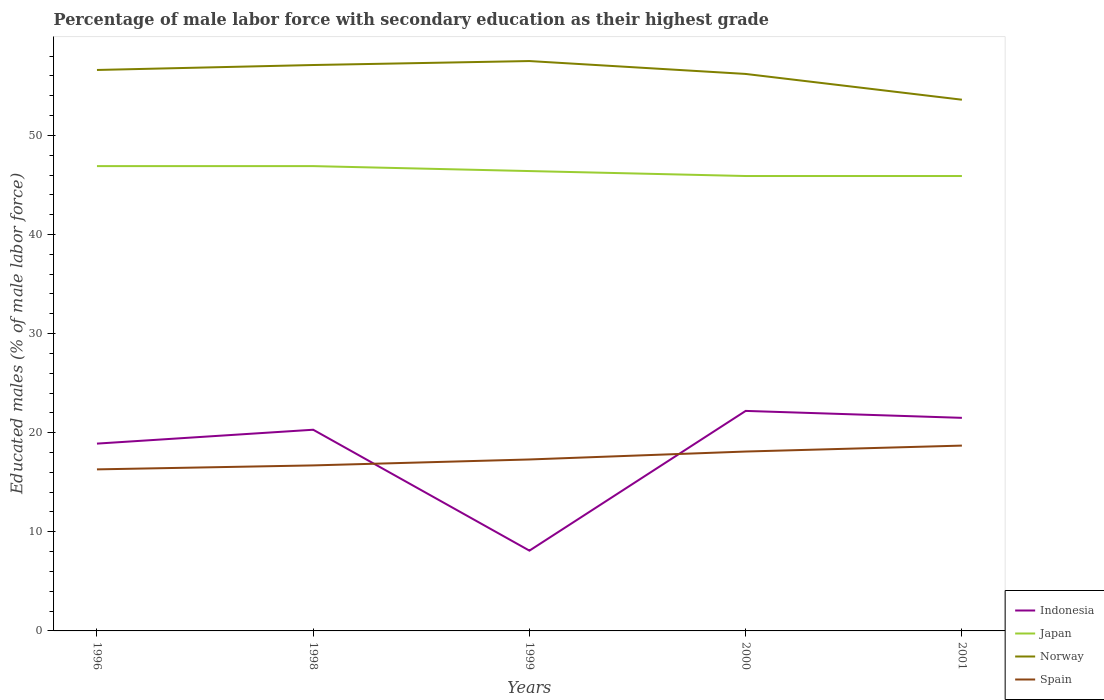How many different coloured lines are there?
Provide a succinct answer. 4. Is the number of lines equal to the number of legend labels?
Keep it short and to the point. Yes. Across all years, what is the maximum percentage of male labor force with secondary education in Spain?
Offer a very short reply. 16.3. What is the total percentage of male labor force with secondary education in Norway in the graph?
Make the answer very short. 0.4. What is the difference between the highest and the second highest percentage of male labor force with secondary education in Norway?
Keep it short and to the point. 3.9. What is the difference between the highest and the lowest percentage of male labor force with secondary education in Indonesia?
Provide a short and direct response. 4. How many years are there in the graph?
Give a very brief answer. 5. What is the difference between two consecutive major ticks on the Y-axis?
Offer a very short reply. 10. Does the graph contain grids?
Offer a terse response. No. Where does the legend appear in the graph?
Ensure brevity in your answer.  Bottom right. How many legend labels are there?
Provide a short and direct response. 4. How are the legend labels stacked?
Offer a terse response. Vertical. What is the title of the graph?
Provide a short and direct response. Percentage of male labor force with secondary education as their highest grade. Does "Congo (Republic)" appear as one of the legend labels in the graph?
Offer a terse response. No. What is the label or title of the Y-axis?
Offer a terse response. Educated males (% of male labor force). What is the Educated males (% of male labor force) of Indonesia in 1996?
Your answer should be compact. 18.9. What is the Educated males (% of male labor force) in Japan in 1996?
Provide a short and direct response. 46.9. What is the Educated males (% of male labor force) of Norway in 1996?
Ensure brevity in your answer.  56.6. What is the Educated males (% of male labor force) of Spain in 1996?
Your response must be concise. 16.3. What is the Educated males (% of male labor force) of Indonesia in 1998?
Ensure brevity in your answer.  20.3. What is the Educated males (% of male labor force) in Japan in 1998?
Ensure brevity in your answer.  46.9. What is the Educated males (% of male labor force) in Norway in 1998?
Offer a terse response. 57.1. What is the Educated males (% of male labor force) of Spain in 1998?
Give a very brief answer. 16.7. What is the Educated males (% of male labor force) in Indonesia in 1999?
Provide a short and direct response. 8.1. What is the Educated males (% of male labor force) in Japan in 1999?
Your answer should be compact. 46.4. What is the Educated males (% of male labor force) of Norway in 1999?
Your answer should be very brief. 57.5. What is the Educated males (% of male labor force) of Spain in 1999?
Make the answer very short. 17.3. What is the Educated males (% of male labor force) of Indonesia in 2000?
Your answer should be compact. 22.2. What is the Educated males (% of male labor force) of Japan in 2000?
Ensure brevity in your answer.  45.9. What is the Educated males (% of male labor force) in Norway in 2000?
Ensure brevity in your answer.  56.2. What is the Educated males (% of male labor force) in Spain in 2000?
Provide a succinct answer. 18.1. What is the Educated males (% of male labor force) in Japan in 2001?
Make the answer very short. 45.9. What is the Educated males (% of male labor force) in Norway in 2001?
Keep it short and to the point. 53.6. What is the Educated males (% of male labor force) in Spain in 2001?
Provide a succinct answer. 18.7. Across all years, what is the maximum Educated males (% of male labor force) in Indonesia?
Give a very brief answer. 22.2. Across all years, what is the maximum Educated males (% of male labor force) of Japan?
Offer a terse response. 46.9. Across all years, what is the maximum Educated males (% of male labor force) of Norway?
Offer a terse response. 57.5. Across all years, what is the maximum Educated males (% of male labor force) in Spain?
Provide a short and direct response. 18.7. Across all years, what is the minimum Educated males (% of male labor force) of Indonesia?
Provide a succinct answer. 8.1. Across all years, what is the minimum Educated males (% of male labor force) of Japan?
Your answer should be very brief. 45.9. Across all years, what is the minimum Educated males (% of male labor force) of Norway?
Make the answer very short. 53.6. Across all years, what is the minimum Educated males (% of male labor force) of Spain?
Your response must be concise. 16.3. What is the total Educated males (% of male labor force) of Indonesia in the graph?
Provide a short and direct response. 91. What is the total Educated males (% of male labor force) of Japan in the graph?
Offer a very short reply. 232. What is the total Educated males (% of male labor force) in Norway in the graph?
Ensure brevity in your answer.  281. What is the total Educated males (% of male labor force) in Spain in the graph?
Your response must be concise. 87.1. What is the difference between the Educated males (% of male labor force) of Indonesia in 1996 and that in 1998?
Provide a succinct answer. -1.4. What is the difference between the Educated males (% of male labor force) in Japan in 1996 and that in 1998?
Offer a very short reply. 0. What is the difference between the Educated males (% of male labor force) in Norway in 1996 and that in 1998?
Your answer should be very brief. -0.5. What is the difference between the Educated males (% of male labor force) of Indonesia in 1996 and that in 1999?
Your answer should be very brief. 10.8. What is the difference between the Educated males (% of male labor force) in Japan in 1996 and that in 1999?
Your response must be concise. 0.5. What is the difference between the Educated males (% of male labor force) of Norway in 1996 and that in 1999?
Your answer should be compact. -0.9. What is the difference between the Educated males (% of male labor force) in Indonesia in 1996 and that in 2000?
Ensure brevity in your answer.  -3.3. What is the difference between the Educated males (% of male labor force) in Spain in 1996 and that in 2000?
Make the answer very short. -1.8. What is the difference between the Educated males (% of male labor force) in Japan in 1996 and that in 2001?
Keep it short and to the point. 1. What is the difference between the Educated males (% of male labor force) of Norway in 1996 and that in 2001?
Your answer should be very brief. 3. What is the difference between the Educated males (% of male labor force) in Spain in 1996 and that in 2001?
Offer a very short reply. -2.4. What is the difference between the Educated males (% of male labor force) in Indonesia in 1998 and that in 1999?
Offer a very short reply. 12.2. What is the difference between the Educated males (% of male labor force) in Japan in 1998 and that in 1999?
Offer a terse response. 0.5. What is the difference between the Educated males (% of male labor force) in Norway in 1998 and that in 1999?
Offer a terse response. -0.4. What is the difference between the Educated males (% of male labor force) of Spain in 1998 and that in 1999?
Offer a terse response. -0.6. What is the difference between the Educated males (% of male labor force) of Norway in 1998 and that in 2000?
Provide a succinct answer. 0.9. What is the difference between the Educated males (% of male labor force) in Spain in 1998 and that in 2000?
Give a very brief answer. -1.4. What is the difference between the Educated males (% of male labor force) of Indonesia in 1998 and that in 2001?
Make the answer very short. -1.2. What is the difference between the Educated males (% of male labor force) of Japan in 1998 and that in 2001?
Offer a very short reply. 1. What is the difference between the Educated males (% of male labor force) of Norway in 1998 and that in 2001?
Your response must be concise. 3.5. What is the difference between the Educated males (% of male labor force) in Spain in 1998 and that in 2001?
Ensure brevity in your answer.  -2. What is the difference between the Educated males (% of male labor force) of Indonesia in 1999 and that in 2000?
Ensure brevity in your answer.  -14.1. What is the difference between the Educated males (% of male labor force) of Japan in 1999 and that in 2000?
Ensure brevity in your answer.  0.5. What is the difference between the Educated males (% of male labor force) of Spain in 1999 and that in 2000?
Provide a succinct answer. -0.8. What is the difference between the Educated males (% of male labor force) of Japan in 1999 and that in 2001?
Offer a terse response. 0.5. What is the difference between the Educated males (% of male labor force) in Spain in 1999 and that in 2001?
Your response must be concise. -1.4. What is the difference between the Educated males (% of male labor force) of Japan in 2000 and that in 2001?
Offer a terse response. 0. What is the difference between the Educated males (% of male labor force) in Spain in 2000 and that in 2001?
Ensure brevity in your answer.  -0.6. What is the difference between the Educated males (% of male labor force) in Indonesia in 1996 and the Educated males (% of male labor force) in Norway in 1998?
Provide a succinct answer. -38.2. What is the difference between the Educated males (% of male labor force) of Indonesia in 1996 and the Educated males (% of male labor force) of Spain in 1998?
Your response must be concise. 2.2. What is the difference between the Educated males (% of male labor force) in Japan in 1996 and the Educated males (% of male labor force) in Spain in 1998?
Provide a short and direct response. 30.2. What is the difference between the Educated males (% of male labor force) of Norway in 1996 and the Educated males (% of male labor force) of Spain in 1998?
Keep it short and to the point. 39.9. What is the difference between the Educated males (% of male labor force) in Indonesia in 1996 and the Educated males (% of male labor force) in Japan in 1999?
Give a very brief answer. -27.5. What is the difference between the Educated males (% of male labor force) in Indonesia in 1996 and the Educated males (% of male labor force) in Norway in 1999?
Your answer should be compact. -38.6. What is the difference between the Educated males (% of male labor force) of Indonesia in 1996 and the Educated males (% of male labor force) of Spain in 1999?
Keep it short and to the point. 1.6. What is the difference between the Educated males (% of male labor force) in Japan in 1996 and the Educated males (% of male labor force) in Spain in 1999?
Your response must be concise. 29.6. What is the difference between the Educated males (% of male labor force) of Norway in 1996 and the Educated males (% of male labor force) of Spain in 1999?
Give a very brief answer. 39.3. What is the difference between the Educated males (% of male labor force) of Indonesia in 1996 and the Educated males (% of male labor force) of Japan in 2000?
Provide a short and direct response. -27. What is the difference between the Educated males (% of male labor force) in Indonesia in 1996 and the Educated males (% of male labor force) in Norway in 2000?
Offer a very short reply. -37.3. What is the difference between the Educated males (% of male labor force) of Indonesia in 1996 and the Educated males (% of male labor force) of Spain in 2000?
Offer a very short reply. 0.8. What is the difference between the Educated males (% of male labor force) in Japan in 1996 and the Educated males (% of male labor force) in Spain in 2000?
Make the answer very short. 28.8. What is the difference between the Educated males (% of male labor force) in Norway in 1996 and the Educated males (% of male labor force) in Spain in 2000?
Keep it short and to the point. 38.5. What is the difference between the Educated males (% of male labor force) of Indonesia in 1996 and the Educated males (% of male labor force) of Norway in 2001?
Provide a succinct answer. -34.7. What is the difference between the Educated males (% of male labor force) in Indonesia in 1996 and the Educated males (% of male labor force) in Spain in 2001?
Your answer should be compact. 0.2. What is the difference between the Educated males (% of male labor force) in Japan in 1996 and the Educated males (% of male labor force) in Norway in 2001?
Your answer should be very brief. -6.7. What is the difference between the Educated males (% of male labor force) in Japan in 1996 and the Educated males (% of male labor force) in Spain in 2001?
Your answer should be compact. 28.2. What is the difference between the Educated males (% of male labor force) in Norway in 1996 and the Educated males (% of male labor force) in Spain in 2001?
Offer a very short reply. 37.9. What is the difference between the Educated males (% of male labor force) in Indonesia in 1998 and the Educated males (% of male labor force) in Japan in 1999?
Provide a short and direct response. -26.1. What is the difference between the Educated males (% of male labor force) in Indonesia in 1998 and the Educated males (% of male labor force) in Norway in 1999?
Your response must be concise. -37.2. What is the difference between the Educated males (% of male labor force) of Japan in 1998 and the Educated males (% of male labor force) of Norway in 1999?
Offer a terse response. -10.6. What is the difference between the Educated males (% of male labor force) in Japan in 1998 and the Educated males (% of male labor force) in Spain in 1999?
Your answer should be very brief. 29.6. What is the difference between the Educated males (% of male labor force) of Norway in 1998 and the Educated males (% of male labor force) of Spain in 1999?
Your answer should be compact. 39.8. What is the difference between the Educated males (% of male labor force) of Indonesia in 1998 and the Educated males (% of male labor force) of Japan in 2000?
Give a very brief answer. -25.6. What is the difference between the Educated males (% of male labor force) in Indonesia in 1998 and the Educated males (% of male labor force) in Norway in 2000?
Your answer should be very brief. -35.9. What is the difference between the Educated males (% of male labor force) of Indonesia in 1998 and the Educated males (% of male labor force) of Spain in 2000?
Offer a terse response. 2.2. What is the difference between the Educated males (% of male labor force) in Japan in 1998 and the Educated males (% of male labor force) in Norway in 2000?
Provide a succinct answer. -9.3. What is the difference between the Educated males (% of male labor force) of Japan in 1998 and the Educated males (% of male labor force) of Spain in 2000?
Give a very brief answer. 28.8. What is the difference between the Educated males (% of male labor force) of Norway in 1998 and the Educated males (% of male labor force) of Spain in 2000?
Your answer should be compact. 39. What is the difference between the Educated males (% of male labor force) in Indonesia in 1998 and the Educated males (% of male labor force) in Japan in 2001?
Your response must be concise. -25.6. What is the difference between the Educated males (% of male labor force) in Indonesia in 1998 and the Educated males (% of male labor force) in Norway in 2001?
Keep it short and to the point. -33.3. What is the difference between the Educated males (% of male labor force) of Japan in 1998 and the Educated males (% of male labor force) of Norway in 2001?
Provide a short and direct response. -6.7. What is the difference between the Educated males (% of male labor force) in Japan in 1998 and the Educated males (% of male labor force) in Spain in 2001?
Make the answer very short. 28.2. What is the difference between the Educated males (% of male labor force) in Norway in 1998 and the Educated males (% of male labor force) in Spain in 2001?
Your response must be concise. 38.4. What is the difference between the Educated males (% of male labor force) in Indonesia in 1999 and the Educated males (% of male labor force) in Japan in 2000?
Your answer should be very brief. -37.8. What is the difference between the Educated males (% of male labor force) in Indonesia in 1999 and the Educated males (% of male labor force) in Norway in 2000?
Provide a succinct answer. -48.1. What is the difference between the Educated males (% of male labor force) in Japan in 1999 and the Educated males (% of male labor force) in Norway in 2000?
Provide a succinct answer. -9.8. What is the difference between the Educated males (% of male labor force) in Japan in 1999 and the Educated males (% of male labor force) in Spain in 2000?
Your response must be concise. 28.3. What is the difference between the Educated males (% of male labor force) in Norway in 1999 and the Educated males (% of male labor force) in Spain in 2000?
Your response must be concise. 39.4. What is the difference between the Educated males (% of male labor force) in Indonesia in 1999 and the Educated males (% of male labor force) in Japan in 2001?
Your answer should be very brief. -37.8. What is the difference between the Educated males (% of male labor force) of Indonesia in 1999 and the Educated males (% of male labor force) of Norway in 2001?
Offer a terse response. -45.5. What is the difference between the Educated males (% of male labor force) in Japan in 1999 and the Educated males (% of male labor force) in Spain in 2001?
Provide a short and direct response. 27.7. What is the difference between the Educated males (% of male labor force) of Norway in 1999 and the Educated males (% of male labor force) of Spain in 2001?
Your answer should be very brief. 38.8. What is the difference between the Educated males (% of male labor force) of Indonesia in 2000 and the Educated males (% of male labor force) of Japan in 2001?
Provide a succinct answer. -23.7. What is the difference between the Educated males (% of male labor force) in Indonesia in 2000 and the Educated males (% of male labor force) in Norway in 2001?
Make the answer very short. -31.4. What is the difference between the Educated males (% of male labor force) of Indonesia in 2000 and the Educated males (% of male labor force) of Spain in 2001?
Provide a succinct answer. 3.5. What is the difference between the Educated males (% of male labor force) of Japan in 2000 and the Educated males (% of male labor force) of Norway in 2001?
Keep it short and to the point. -7.7. What is the difference between the Educated males (% of male labor force) of Japan in 2000 and the Educated males (% of male labor force) of Spain in 2001?
Your answer should be compact. 27.2. What is the difference between the Educated males (% of male labor force) in Norway in 2000 and the Educated males (% of male labor force) in Spain in 2001?
Give a very brief answer. 37.5. What is the average Educated males (% of male labor force) of Japan per year?
Make the answer very short. 46.4. What is the average Educated males (% of male labor force) in Norway per year?
Your answer should be compact. 56.2. What is the average Educated males (% of male labor force) in Spain per year?
Make the answer very short. 17.42. In the year 1996, what is the difference between the Educated males (% of male labor force) of Indonesia and Educated males (% of male labor force) of Norway?
Your answer should be compact. -37.7. In the year 1996, what is the difference between the Educated males (% of male labor force) of Indonesia and Educated males (% of male labor force) of Spain?
Make the answer very short. 2.6. In the year 1996, what is the difference between the Educated males (% of male labor force) in Japan and Educated males (% of male labor force) in Norway?
Your response must be concise. -9.7. In the year 1996, what is the difference between the Educated males (% of male labor force) of Japan and Educated males (% of male labor force) of Spain?
Ensure brevity in your answer.  30.6. In the year 1996, what is the difference between the Educated males (% of male labor force) of Norway and Educated males (% of male labor force) of Spain?
Provide a short and direct response. 40.3. In the year 1998, what is the difference between the Educated males (% of male labor force) of Indonesia and Educated males (% of male labor force) of Japan?
Offer a terse response. -26.6. In the year 1998, what is the difference between the Educated males (% of male labor force) in Indonesia and Educated males (% of male labor force) in Norway?
Make the answer very short. -36.8. In the year 1998, what is the difference between the Educated males (% of male labor force) in Japan and Educated males (% of male labor force) in Norway?
Make the answer very short. -10.2. In the year 1998, what is the difference between the Educated males (% of male labor force) in Japan and Educated males (% of male labor force) in Spain?
Your response must be concise. 30.2. In the year 1998, what is the difference between the Educated males (% of male labor force) of Norway and Educated males (% of male labor force) of Spain?
Your answer should be very brief. 40.4. In the year 1999, what is the difference between the Educated males (% of male labor force) in Indonesia and Educated males (% of male labor force) in Japan?
Offer a very short reply. -38.3. In the year 1999, what is the difference between the Educated males (% of male labor force) of Indonesia and Educated males (% of male labor force) of Norway?
Your answer should be compact. -49.4. In the year 1999, what is the difference between the Educated males (% of male labor force) in Indonesia and Educated males (% of male labor force) in Spain?
Offer a terse response. -9.2. In the year 1999, what is the difference between the Educated males (% of male labor force) in Japan and Educated males (% of male labor force) in Spain?
Your response must be concise. 29.1. In the year 1999, what is the difference between the Educated males (% of male labor force) in Norway and Educated males (% of male labor force) in Spain?
Offer a terse response. 40.2. In the year 2000, what is the difference between the Educated males (% of male labor force) in Indonesia and Educated males (% of male labor force) in Japan?
Provide a succinct answer. -23.7. In the year 2000, what is the difference between the Educated males (% of male labor force) in Indonesia and Educated males (% of male labor force) in Norway?
Give a very brief answer. -34. In the year 2000, what is the difference between the Educated males (% of male labor force) of Indonesia and Educated males (% of male labor force) of Spain?
Offer a very short reply. 4.1. In the year 2000, what is the difference between the Educated males (% of male labor force) of Japan and Educated males (% of male labor force) of Spain?
Give a very brief answer. 27.8. In the year 2000, what is the difference between the Educated males (% of male labor force) of Norway and Educated males (% of male labor force) of Spain?
Provide a succinct answer. 38.1. In the year 2001, what is the difference between the Educated males (% of male labor force) in Indonesia and Educated males (% of male labor force) in Japan?
Ensure brevity in your answer.  -24.4. In the year 2001, what is the difference between the Educated males (% of male labor force) of Indonesia and Educated males (% of male labor force) of Norway?
Give a very brief answer. -32.1. In the year 2001, what is the difference between the Educated males (% of male labor force) in Indonesia and Educated males (% of male labor force) in Spain?
Keep it short and to the point. 2.8. In the year 2001, what is the difference between the Educated males (% of male labor force) of Japan and Educated males (% of male labor force) of Norway?
Offer a very short reply. -7.7. In the year 2001, what is the difference between the Educated males (% of male labor force) in Japan and Educated males (% of male labor force) in Spain?
Offer a terse response. 27.2. In the year 2001, what is the difference between the Educated males (% of male labor force) in Norway and Educated males (% of male labor force) in Spain?
Your answer should be very brief. 34.9. What is the ratio of the Educated males (% of male labor force) of Japan in 1996 to that in 1998?
Provide a short and direct response. 1. What is the ratio of the Educated males (% of male labor force) in Norway in 1996 to that in 1998?
Give a very brief answer. 0.99. What is the ratio of the Educated males (% of male labor force) of Spain in 1996 to that in 1998?
Provide a short and direct response. 0.98. What is the ratio of the Educated males (% of male labor force) of Indonesia in 1996 to that in 1999?
Keep it short and to the point. 2.33. What is the ratio of the Educated males (% of male labor force) of Japan in 1996 to that in 1999?
Offer a terse response. 1.01. What is the ratio of the Educated males (% of male labor force) of Norway in 1996 to that in 1999?
Ensure brevity in your answer.  0.98. What is the ratio of the Educated males (% of male labor force) in Spain in 1996 to that in 1999?
Your response must be concise. 0.94. What is the ratio of the Educated males (% of male labor force) in Indonesia in 1996 to that in 2000?
Keep it short and to the point. 0.85. What is the ratio of the Educated males (% of male labor force) in Japan in 1996 to that in 2000?
Keep it short and to the point. 1.02. What is the ratio of the Educated males (% of male labor force) in Norway in 1996 to that in 2000?
Offer a terse response. 1.01. What is the ratio of the Educated males (% of male labor force) in Spain in 1996 to that in 2000?
Your response must be concise. 0.9. What is the ratio of the Educated males (% of male labor force) of Indonesia in 1996 to that in 2001?
Provide a succinct answer. 0.88. What is the ratio of the Educated males (% of male labor force) of Japan in 1996 to that in 2001?
Make the answer very short. 1.02. What is the ratio of the Educated males (% of male labor force) in Norway in 1996 to that in 2001?
Offer a very short reply. 1.06. What is the ratio of the Educated males (% of male labor force) of Spain in 1996 to that in 2001?
Offer a very short reply. 0.87. What is the ratio of the Educated males (% of male labor force) of Indonesia in 1998 to that in 1999?
Offer a very short reply. 2.51. What is the ratio of the Educated males (% of male labor force) of Japan in 1998 to that in 1999?
Ensure brevity in your answer.  1.01. What is the ratio of the Educated males (% of male labor force) in Spain in 1998 to that in 1999?
Your answer should be very brief. 0.97. What is the ratio of the Educated males (% of male labor force) in Indonesia in 1998 to that in 2000?
Make the answer very short. 0.91. What is the ratio of the Educated males (% of male labor force) of Japan in 1998 to that in 2000?
Keep it short and to the point. 1.02. What is the ratio of the Educated males (% of male labor force) in Norway in 1998 to that in 2000?
Your response must be concise. 1.02. What is the ratio of the Educated males (% of male labor force) in Spain in 1998 to that in 2000?
Your answer should be very brief. 0.92. What is the ratio of the Educated males (% of male labor force) in Indonesia in 1998 to that in 2001?
Offer a very short reply. 0.94. What is the ratio of the Educated males (% of male labor force) in Japan in 1998 to that in 2001?
Give a very brief answer. 1.02. What is the ratio of the Educated males (% of male labor force) of Norway in 1998 to that in 2001?
Provide a succinct answer. 1.07. What is the ratio of the Educated males (% of male labor force) in Spain in 1998 to that in 2001?
Ensure brevity in your answer.  0.89. What is the ratio of the Educated males (% of male labor force) in Indonesia in 1999 to that in 2000?
Provide a short and direct response. 0.36. What is the ratio of the Educated males (% of male labor force) of Japan in 1999 to that in 2000?
Your answer should be very brief. 1.01. What is the ratio of the Educated males (% of male labor force) in Norway in 1999 to that in 2000?
Ensure brevity in your answer.  1.02. What is the ratio of the Educated males (% of male labor force) of Spain in 1999 to that in 2000?
Provide a succinct answer. 0.96. What is the ratio of the Educated males (% of male labor force) in Indonesia in 1999 to that in 2001?
Provide a short and direct response. 0.38. What is the ratio of the Educated males (% of male labor force) in Japan in 1999 to that in 2001?
Keep it short and to the point. 1.01. What is the ratio of the Educated males (% of male labor force) in Norway in 1999 to that in 2001?
Your answer should be very brief. 1.07. What is the ratio of the Educated males (% of male labor force) of Spain in 1999 to that in 2001?
Keep it short and to the point. 0.93. What is the ratio of the Educated males (% of male labor force) of Indonesia in 2000 to that in 2001?
Your response must be concise. 1.03. What is the ratio of the Educated males (% of male labor force) in Japan in 2000 to that in 2001?
Provide a short and direct response. 1. What is the ratio of the Educated males (% of male labor force) in Norway in 2000 to that in 2001?
Your response must be concise. 1.05. What is the ratio of the Educated males (% of male labor force) of Spain in 2000 to that in 2001?
Keep it short and to the point. 0.97. What is the difference between the highest and the second highest Educated males (% of male labor force) in Norway?
Offer a very short reply. 0.4. What is the difference between the highest and the second highest Educated males (% of male labor force) of Spain?
Offer a terse response. 0.6. What is the difference between the highest and the lowest Educated males (% of male labor force) of Norway?
Your answer should be compact. 3.9. 